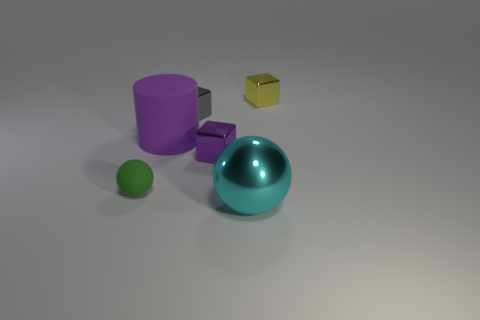How many objects are in the image, and can you describe their colors? The image contains a collection of five objects. From left to right, there's a small green sphere, a large purple cylinder, a small purple cube, a glossy teal sphere, and a small golden yellow cube. 